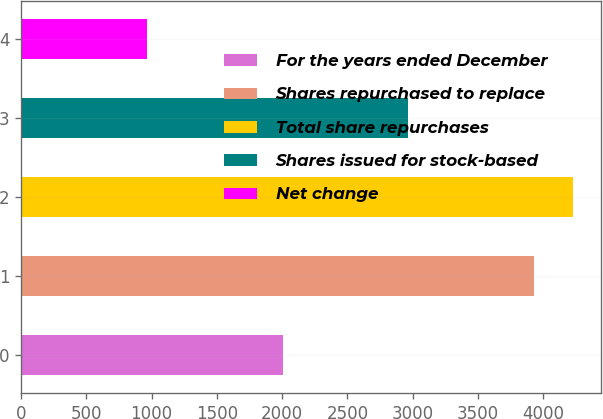Convert chart to OTSL. <chart><loc_0><loc_0><loc_500><loc_500><bar_chart><fcel>For the years ended December<fcel>Shares repurchased to replace<fcel>Total share repurchases<fcel>Shares issued for stock-based<fcel>Net change<nl><fcel>2010<fcel>3932<fcel>4228.4<fcel>2964<fcel>968<nl></chart> 